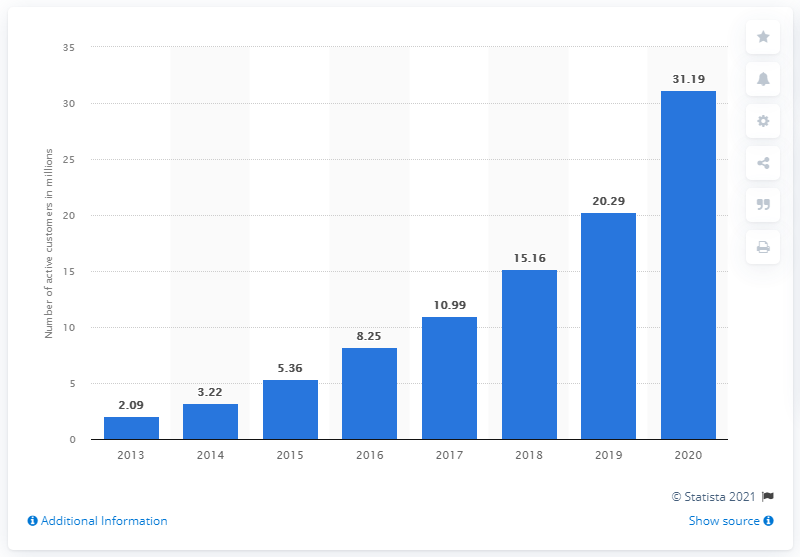Highlight a few significant elements in this photo. In the previous year, Wayfair had approximately 20.29 customers. During the last fiscal period, Wayfair had a total of 31,190 customers. 